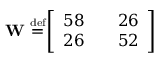Convert formula to latex. <formula><loc_0><loc_0><loc_500><loc_500>W \ { \overset { \underset { d e f } { = } } { \left [ \begin{array} { l l l } { 5 8 } & { 2 6 } \\ { 2 6 } & { 5 2 } \end{array} \right ] }</formula> 